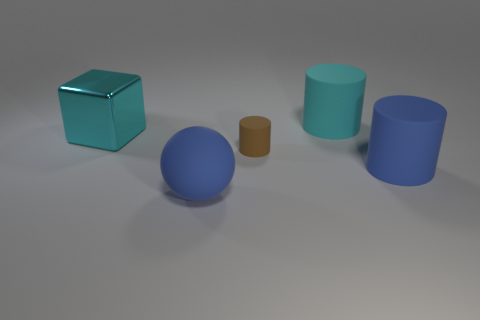Subtract all blue cylinders. How many cylinders are left? 2 Add 2 brown rubber objects. How many objects exist? 7 Subtract all blue cylinders. How many cylinders are left? 2 Subtract 1 blocks. How many blocks are left? 0 Subtract 1 cyan blocks. How many objects are left? 4 Subtract all spheres. How many objects are left? 4 Subtract all cyan cylinders. Subtract all cyan blocks. How many cylinders are left? 2 Subtract all gray balls. How many blue cylinders are left? 1 Subtract all big cyan spheres. Subtract all rubber objects. How many objects are left? 1 Add 2 cyan metallic blocks. How many cyan metallic blocks are left? 3 